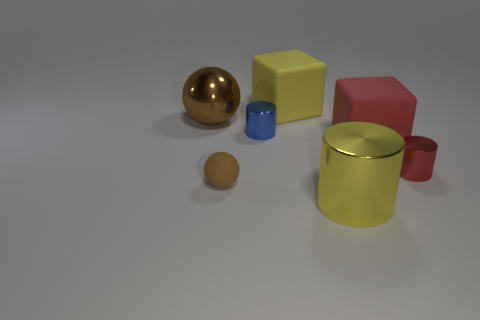What is the size of the matte thing that is the same color as the metal ball?
Provide a succinct answer. Small. What is the size of the red object that is made of the same material as the large sphere?
Provide a short and direct response. Small. The yellow thing behind the ball that is behind the small metallic object that is right of the large yellow rubber object is what shape?
Provide a succinct answer. Cube. The yellow object that is the same shape as the small blue metal thing is what size?
Your answer should be very brief. Large. What size is the object that is both to the left of the blue metallic object and in front of the large brown object?
Keep it short and to the point. Small. What is the shape of the thing that is the same color as the small rubber sphere?
Your answer should be very brief. Sphere. The large sphere has what color?
Your answer should be very brief. Brown. There is a rubber thing that is on the left side of the blue cylinder; what size is it?
Provide a short and direct response. Small. There is a large block that is in front of the big yellow object behind the tiny brown object; what number of big objects are behind it?
Ensure brevity in your answer.  2. What is the color of the ball that is in front of the small metallic object to the left of the red matte object?
Provide a succinct answer. Brown. 